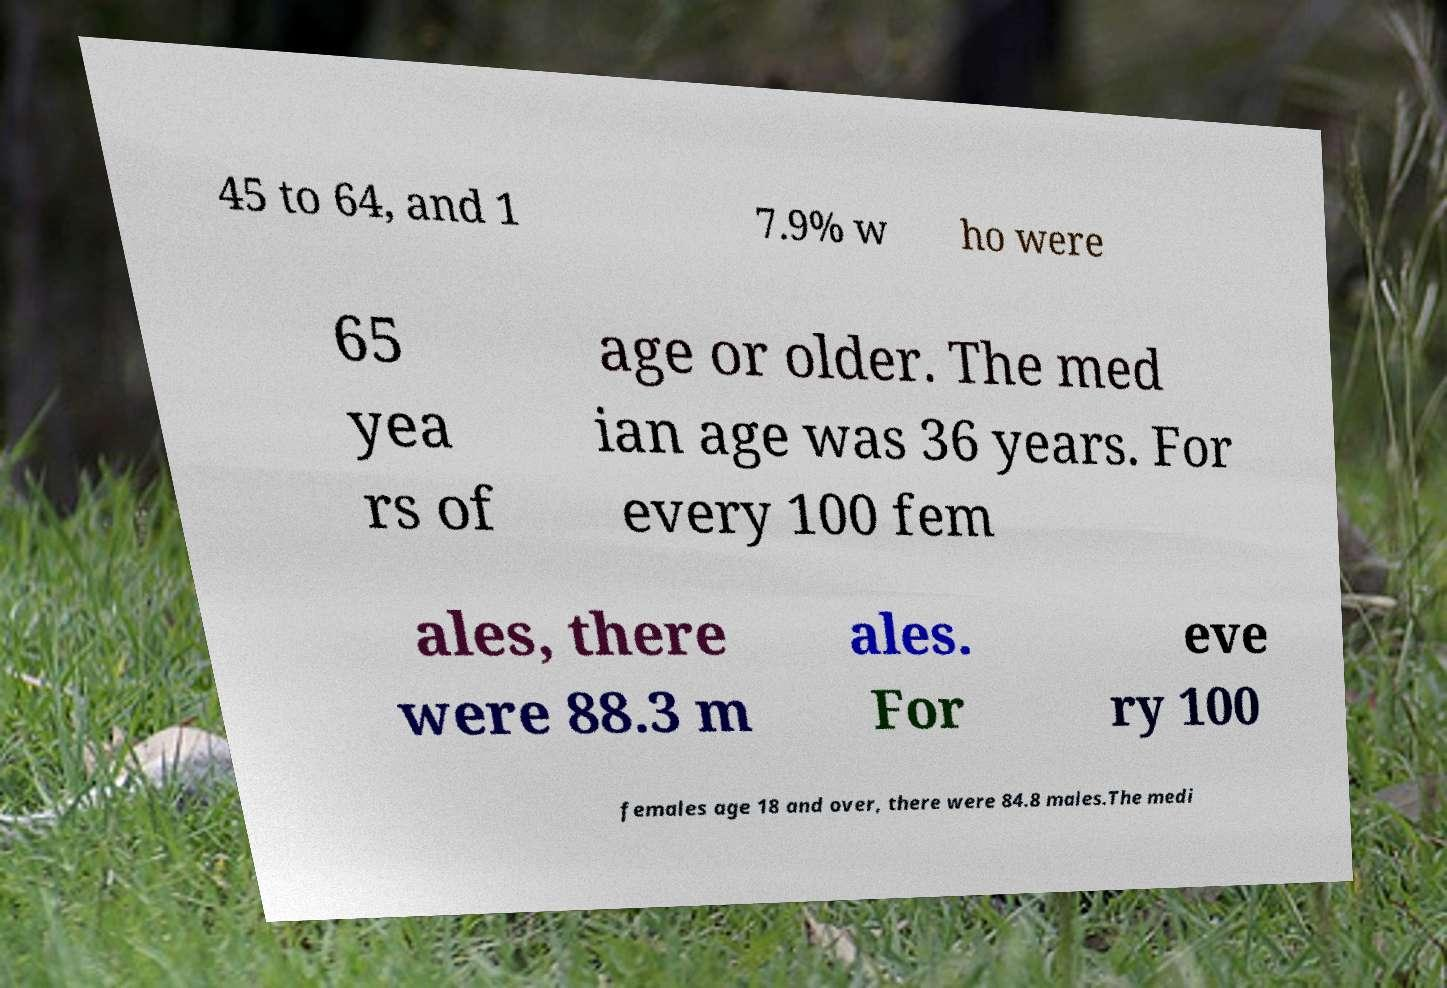Can you accurately transcribe the text from the provided image for me? 45 to 64, and 1 7.9% w ho were 65 yea rs of age or older. The med ian age was 36 years. For every 100 fem ales, there were 88.3 m ales. For eve ry 100 females age 18 and over, there were 84.8 males.The medi 